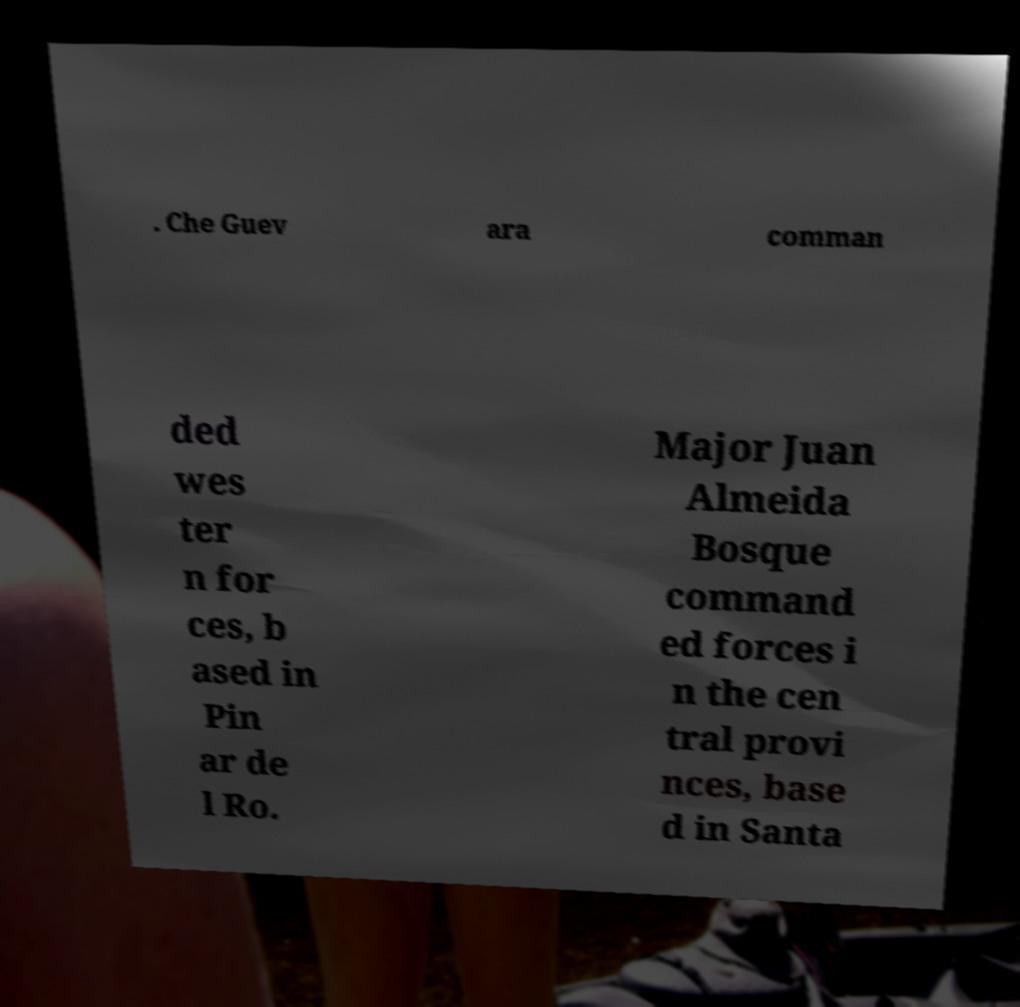I need the written content from this picture converted into text. Can you do that? . Che Guev ara comman ded wes ter n for ces, b ased in Pin ar de l Ro. Major Juan Almeida Bosque command ed forces i n the cen tral provi nces, base d in Santa 